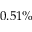Convert formula to latex. <formula><loc_0><loc_0><loc_500><loc_500>0 . 5 1 \%</formula> 